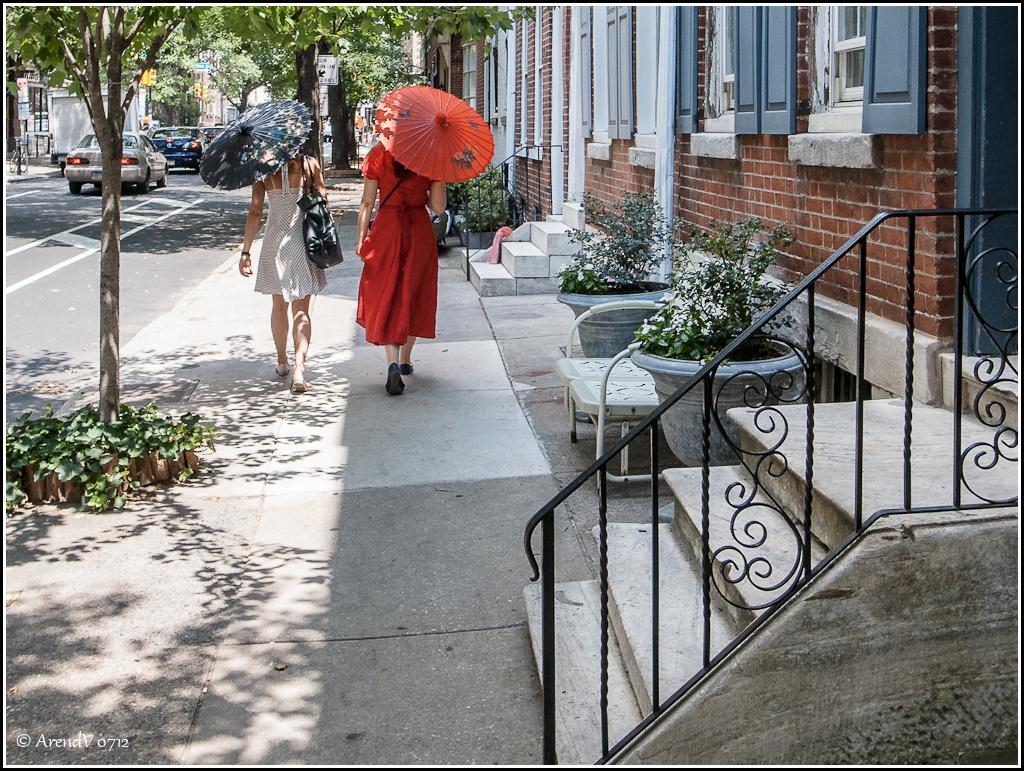In one or two sentences, can you explain what this image depicts? In the picture I can see two women walking and holding an umbrella in their hands and there are few plants and buildings in the right corner and there are few trees,vehicles and buildings in the background. 